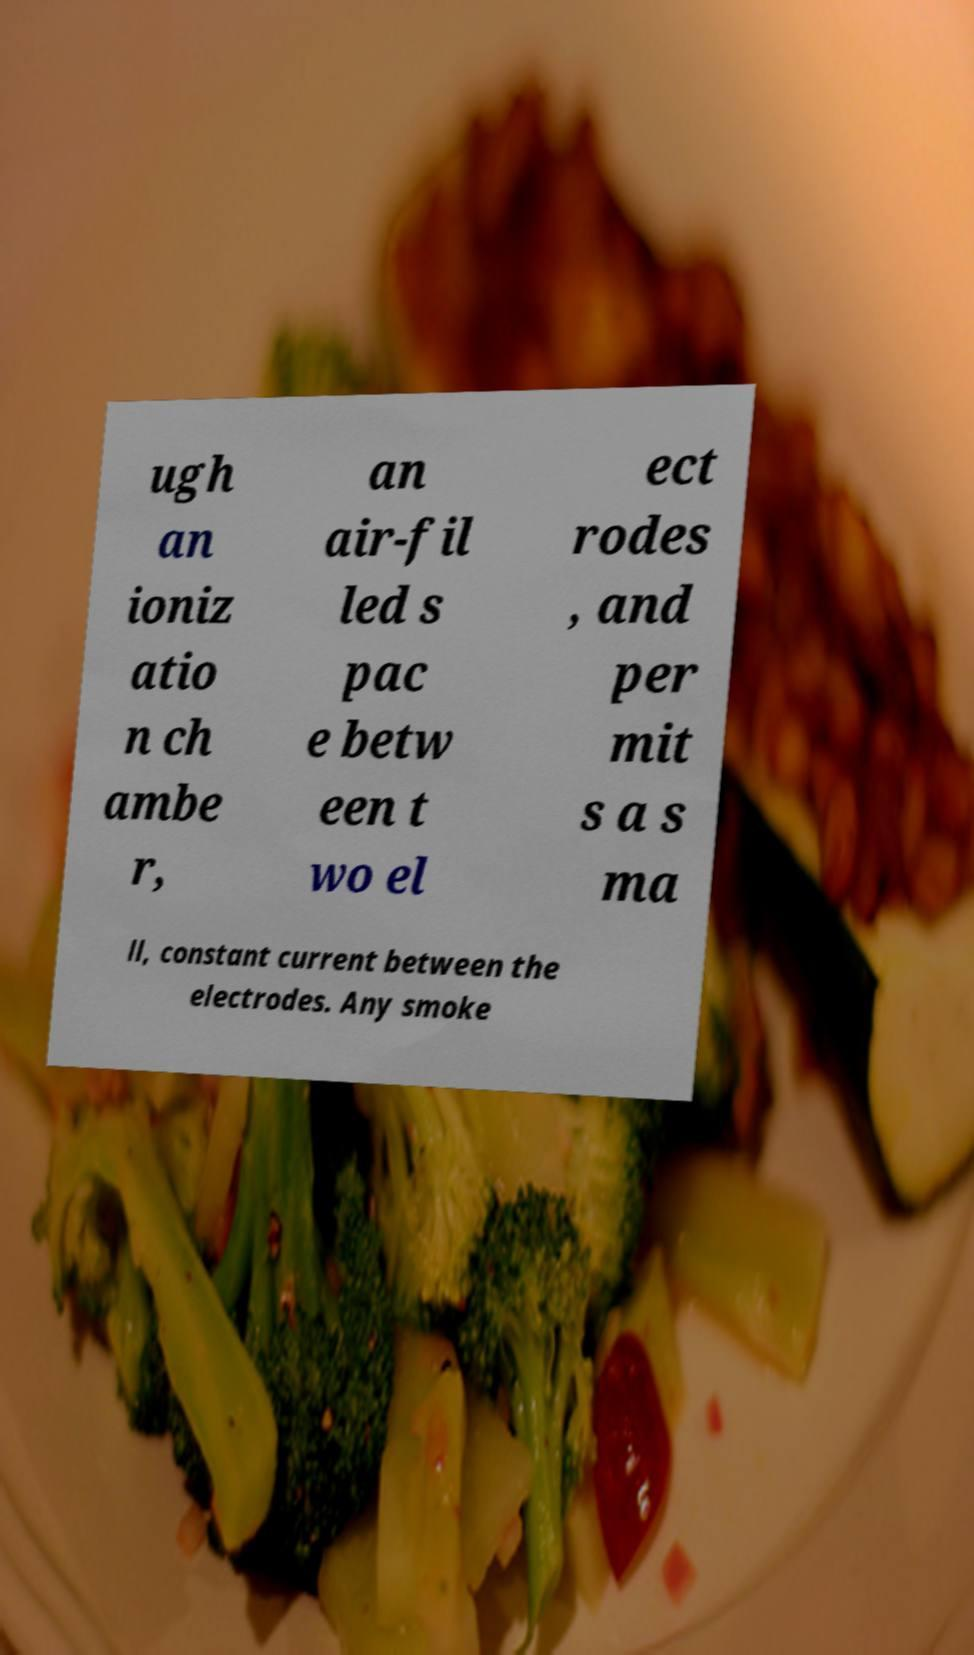Please identify and transcribe the text found in this image. ugh an ioniz atio n ch ambe r, an air-fil led s pac e betw een t wo el ect rodes , and per mit s a s ma ll, constant current between the electrodes. Any smoke 